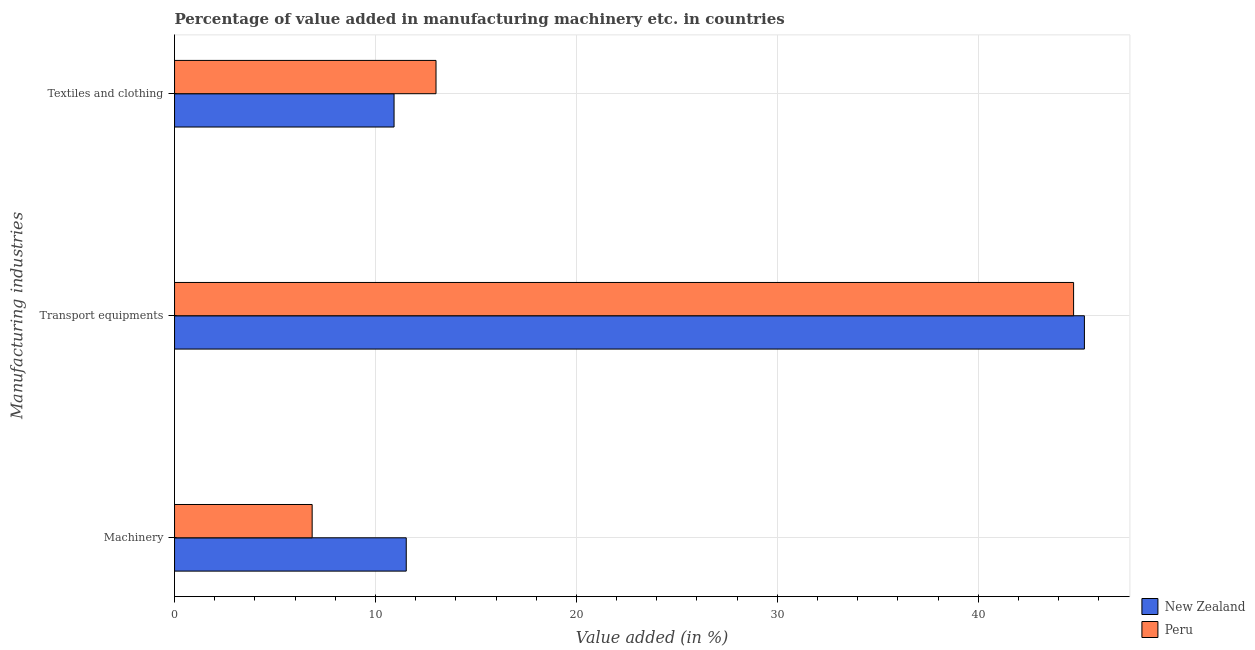How many groups of bars are there?
Offer a very short reply. 3. What is the label of the 3rd group of bars from the top?
Ensure brevity in your answer.  Machinery. What is the value added in manufacturing transport equipments in New Zealand?
Give a very brief answer. 45.29. Across all countries, what is the maximum value added in manufacturing transport equipments?
Your answer should be compact. 45.29. Across all countries, what is the minimum value added in manufacturing textile and clothing?
Offer a terse response. 10.93. In which country was the value added in manufacturing transport equipments maximum?
Give a very brief answer. New Zealand. In which country was the value added in manufacturing textile and clothing minimum?
Provide a short and direct response. New Zealand. What is the total value added in manufacturing transport equipments in the graph?
Ensure brevity in your answer.  90.04. What is the difference between the value added in manufacturing transport equipments in Peru and that in New Zealand?
Ensure brevity in your answer.  -0.54. What is the difference between the value added in manufacturing textile and clothing in New Zealand and the value added in manufacturing transport equipments in Peru?
Your answer should be very brief. -33.82. What is the average value added in manufacturing machinery per country?
Offer a very short reply. 9.19. What is the difference between the value added in manufacturing textile and clothing and value added in manufacturing machinery in Peru?
Offer a terse response. 6.16. What is the ratio of the value added in manufacturing textile and clothing in New Zealand to that in Peru?
Make the answer very short. 0.84. What is the difference between the highest and the second highest value added in manufacturing transport equipments?
Provide a succinct answer. 0.54. What is the difference between the highest and the lowest value added in manufacturing machinery?
Offer a terse response. 4.68. Is the sum of the value added in manufacturing transport equipments in Peru and New Zealand greater than the maximum value added in manufacturing machinery across all countries?
Make the answer very short. Yes. What does the 2nd bar from the top in Textiles and clothing represents?
Provide a succinct answer. New Zealand. What does the 2nd bar from the bottom in Transport equipments represents?
Make the answer very short. Peru. Is it the case that in every country, the sum of the value added in manufacturing machinery and value added in manufacturing transport equipments is greater than the value added in manufacturing textile and clothing?
Ensure brevity in your answer.  Yes. How many bars are there?
Your answer should be compact. 6. How many countries are there in the graph?
Make the answer very short. 2. Does the graph contain any zero values?
Ensure brevity in your answer.  No. Does the graph contain grids?
Offer a terse response. Yes. How are the legend labels stacked?
Your response must be concise. Vertical. What is the title of the graph?
Provide a short and direct response. Percentage of value added in manufacturing machinery etc. in countries. Does "Marshall Islands" appear as one of the legend labels in the graph?
Give a very brief answer. No. What is the label or title of the X-axis?
Ensure brevity in your answer.  Value added (in %). What is the label or title of the Y-axis?
Ensure brevity in your answer.  Manufacturing industries. What is the Value added (in %) in New Zealand in Machinery?
Your response must be concise. 11.53. What is the Value added (in %) in Peru in Machinery?
Your response must be concise. 6.85. What is the Value added (in %) of New Zealand in Transport equipments?
Give a very brief answer. 45.29. What is the Value added (in %) of Peru in Transport equipments?
Give a very brief answer. 44.75. What is the Value added (in %) of New Zealand in Textiles and clothing?
Your answer should be compact. 10.93. What is the Value added (in %) of Peru in Textiles and clothing?
Keep it short and to the point. 13.01. Across all Manufacturing industries, what is the maximum Value added (in %) of New Zealand?
Your answer should be very brief. 45.29. Across all Manufacturing industries, what is the maximum Value added (in %) in Peru?
Offer a very short reply. 44.75. Across all Manufacturing industries, what is the minimum Value added (in %) in New Zealand?
Provide a short and direct response. 10.93. Across all Manufacturing industries, what is the minimum Value added (in %) in Peru?
Keep it short and to the point. 6.85. What is the total Value added (in %) in New Zealand in the graph?
Give a very brief answer. 67.75. What is the total Value added (in %) of Peru in the graph?
Your answer should be very brief. 64.61. What is the difference between the Value added (in %) of New Zealand in Machinery and that in Transport equipments?
Make the answer very short. -33.75. What is the difference between the Value added (in %) in Peru in Machinery and that in Transport equipments?
Provide a short and direct response. -37.9. What is the difference between the Value added (in %) of New Zealand in Machinery and that in Textiles and clothing?
Your answer should be compact. 0.61. What is the difference between the Value added (in %) in Peru in Machinery and that in Textiles and clothing?
Ensure brevity in your answer.  -6.16. What is the difference between the Value added (in %) of New Zealand in Transport equipments and that in Textiles and clothing?
Offer a terse response. 34.36. What is the difference between the Value added (in %) in Peru in Transport equipments and that in Textiles and clothing?
Offer a very short reply. 31.74. What is the difference between the Value added (in %) of New Zealand in Machinery and the Value added (in %) of Peru in Transport equipments?
Ensure brevity in your answer.  -33.22. What is the difference between the Value added (in %) in New Zealand in Machinery and the Value added (in %) in Peru in Textiles and clothing?
Provide a succinct answer. -1.48. What is the difference between the Value added (in %) in New Zealand in Transport equipments and the Value added (in %) in Peru in Textiles and clothing?
Give a very brief answer. 32.27. What is the average Value added (in %) of New Zealand per Manufacturing industries?
Your answer should be very brief. 22.58. What is the average Value added (in %) of Peru per Manufacturing industries?
Keep it short and to the point. 21.54. What is the difference between the Value added (in %) in New Zealand and Value added (in %) in Peru in Machinery?
Your response must be concise. 4.68. What is the difference between the Value added (in %) in New Zealand and Value added (in %) in Peru in Transport equipments?
Provide a succinct answer. 0.54. What is the difference between the Value added (in %) in New Zealand and Value added (in %) in Peru in Textiles and clothing?
Offer a terse response. -2.09. What is the ratio of the Value added (in %) of New Zealand in Machinery to that in Transport equipments?
Your answer should be very brief. 0.25. What is the ratio of the Value added (in %) in Peru in Machinery to that in Transport equipments?
Offer a terse response. 0.15. What is the ratio of the Value added (in %) of New Zealand in Machinery to that in Textiles and clothing?
Your response must be concise. 1.06. What is the ratio of the Value added (in %) in Peru in Machinery to that in Textiles and clothing?
Offer a terse response. 0.53. What is the ratio of the Value added (in %) of New Zealand in Transport equipments to that in Textiles and clothing?
Your response must be concise. 4.14. What is the ratio of the Value added (in %) of Peru in Transport equipments to that in Textiles and clothing?
Ensure brevity in your answer.  3.44. What is the difference between the highest and the second highest Value added (in %) in New Zealand?
Ensure brevity in your answer.  33.75. What is the difference between the highest and the second highest Value added (in %) in Peru?
Give a very brief answer. 31.74. What is the difference between the highest and the lowest Value added (in %) in New Zealand?
Provide a short and direct response. 34.36. What is the difference between the highest and the lowest Value added (in %) of Peru?
Keep it short and to the point. 37.9. 